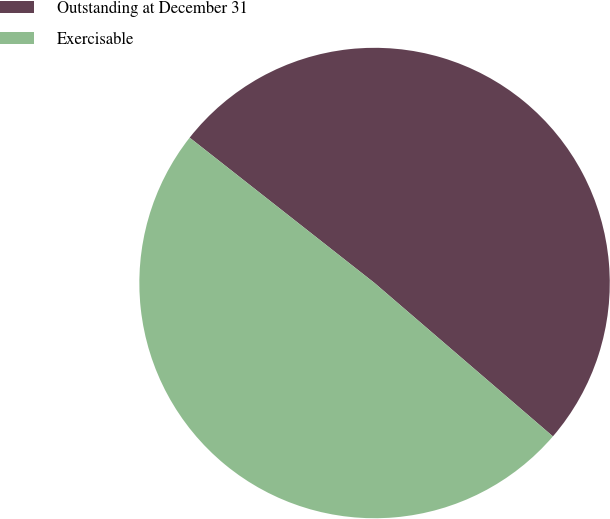Convert chart. <chart><loc_0><loc_0><loc_500><loc_500><pie_chart><fcel>Outstanding at December 31<fcel>Exercisable<nl><fcel>50.7%<fcel>49.3%<nl></chart> 